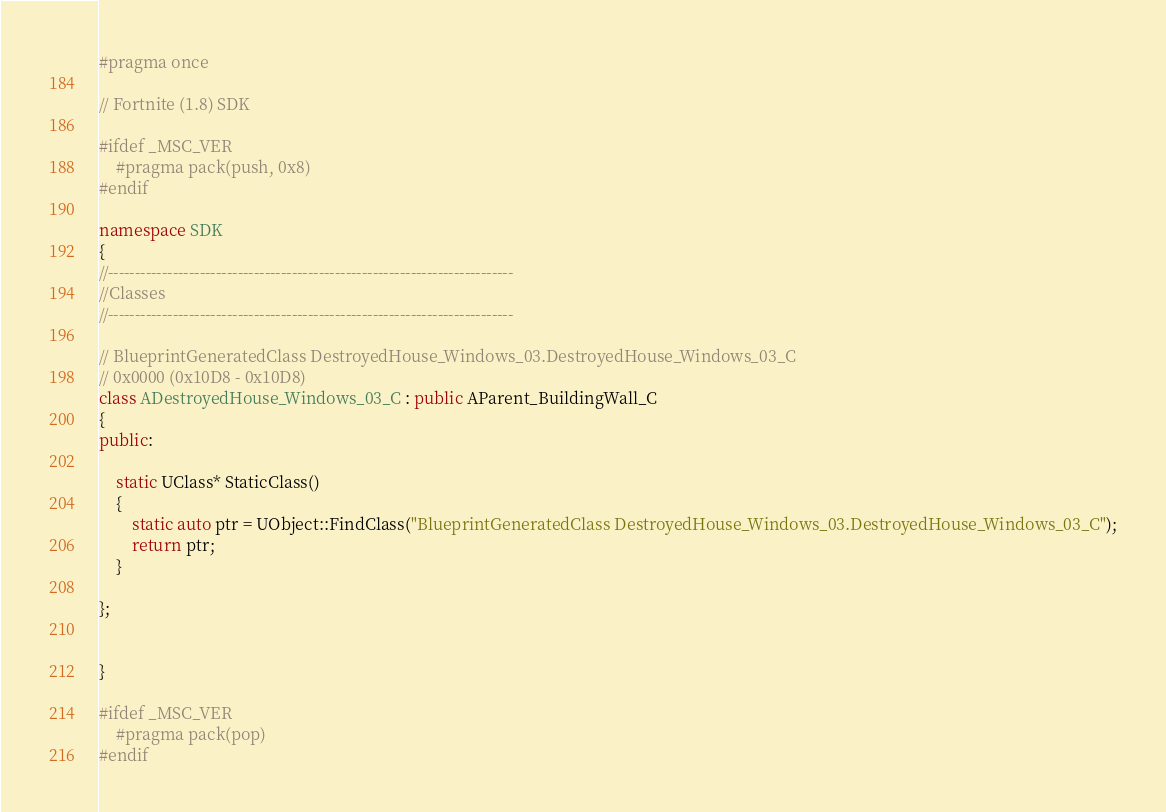<code> <loc_0><loc_0><loc_500><loc_500><_C++_>#pragma once

// Fortnite (1.8) SDK

#ifdef _MSC_VER
	#pragma pack(push, 0x8)
#endif

namespace SDK
{
//---------------------------------------------------------------------------
//Classes
//---------------------------------------------------------------------------

// BlueprintGeneratedClass DestroyedHouse_Windows_03.DestroyedHouse_Windows_03_C
// 0x0000 (0x10D8 - 0x10D8)
class ADestroyedHouse_Windows_03_C : public AParent_BuildingWall_C
{
public:

	static UClass* StaticClass()
	{
		static auto ptr = UObject::FindClass("BlueprintGeneratedClass DestroyedHouse_Windows_03.DestroyedHouse_Windows_03_C");
		return ptr;
	}

};


}

#ifdef _MSC_VER
	#pragma pack(pop)
#endif
</code> 